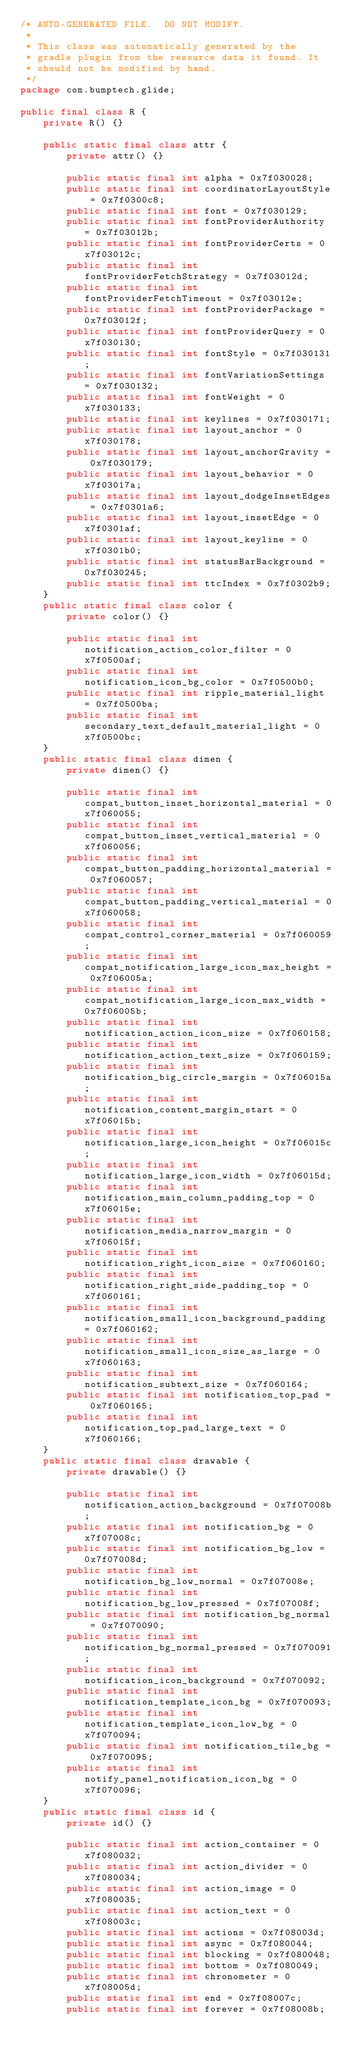<code> <loc_0><loc_0><loc_500><loc_500><_Java_>/* AUTO-GENERATED FILE.  DO NOT MODIFY.
 *
 * This class was automatically generated by the
 * gradle plugin from the resource data it found. It
 * should not be modified by hand.
 */
package com.bumptech.glide;

public final class R {
    private R() {}

    public static final class attr {
        private attr() {}

        public static final int alpha = 0x7f030028;
        public static final int coordinatorLayoutStyle = 0x7f0300c8;
        public static final int font = 0x7f030129;
        public static final int fontProviderAuthority = 0x7f03012b;
        public static final int fontProviderCerts = 0x7f03012c;
        public static final int fontProviderFetchStrategy = 0x7f03012d;
        public static final int fontProviderFetchTimeout = 0x7f03012e;
        public static final int fontProviderPackage = 0x7f03012f;
        public static final int fontProviderQuery = 0x7f030130;
        public static final int fontStyle = 0x7f030131;
        public static final int fontVariationSettings = 0x7f030132;
        public static final int fontWeight = 0x7f030133;
        public static final int keylines = 0x7f030171;
        public static final int layout_anchor = 0x7f030178;
        public static final int layout_anchorGravity = 0x7f030179;
        public static final int layout_behavior = 0x7f03017a;
        public static final int layout_dodgeInsetEdges = 0x7f0301a6;
        public static final int layout_insetEdge = 0x7f0301af;
        public static final int layout_keyline = 0x7f0301b0;
        public static final int statusBarBackground = 0x7f030245;
        public static final int ttcIndex = 0x7f0302b9;
    }
    public static final class color {
        private color() {}

        public static final int notification_action_color_filter = 0x7f0500af;
        public static final int notification_icon_bg_color = 0x7f0500b0;
        public static final int ripple_material_light = 0x7f0500ba;
        public static final int secondary_text_default_material_light = 0x7f0500bc;
    }
    public static final class dimen {
        private dimen() {}

        public static final int compat_button_inset_horizontal_material = 0x7f060055;
        public static final int compat_button_inset_vertical_material = 0x7f060056;
        public static final int compat_button_padding_horizontal_material = 0x7f060057;
        public static final int compat_button_padding_vertical_material = 0x7f060058;
        public static final int compat_control_corner_material = 0x7f060059;
        public static final int compat_notification_large_icon_max_height = 0x7f06005a;
        public static final int compat_notification_large_icon_max_width = 0x7f06005b;
        public static final int notification_action_icon_size = 0x7f060158;
        public static final int notification_action_text_size = 0x7f060159;
        public static final int notification_big_circle_margin = 0x7f06015a;
        public static final int notification_content_margin_start = 0x7f06015b;
        public static final int notification_large_icon_height = 0x7f06015c;
        public static final int notification_large_icon_width = 0x7f06015d;
        public static final int notification_main_column_padding_top = 0x7f06015e;
        public static final int notification_media_narrow_margin = 0x7f06015f;
        public static final int notification_right_icon_size = 0x7f060160;
        public static final int notification_right_side_padding_top = 0x7f060161;
        public static final int notification_small_icon_background_padding = 0x7f060162;
        public static final int notification_small_icon_size_as_large = 0x7f060163;
        public static final int notification_subtext_size = 0x7f060164;
        public static final int notification_top_pad = 0x7f060165;
        public static final int notification_top_pad_large_text = 0x7f060166;
    }
    public static final class drawable {
        private drawable() {}

        public static final int notification_action_background = 0x7f07008b;
        public static final int notification_bg = 0x7f07008c;
        public static final int notification_bg_low = 0x7f07008d;
        public static final int notification_bg_low_normal = 0x7f07008e;
        public static final int notification_bg_low_pressed = 0x7f07008f;
        public static final int notification_bg_normal = 0x7f070090;
        public static final int notification_bg_normal_pressed = 0x7f070091;
        public static final int notification_icon_background = 0x7f070092;
        public static final int notification_template_icon_bg = 0x7f070093;
        public static final int notification_template_icon_low_bg = 0x7f070094;
        public static final int notification_tile_bg = 0x7f070095;
        public static final int notify_panel_notification_icon_bg = 0x7f070096;
    }
    public static final class id {
        private id() {}

        public static final int action_container = 0x7f080032;
        public static final int action_divider = 0x7f080034;
        public static final int action_image = 0x7f080035;
        public static final int action_text = 0x7f08003c;
        public static final int actions = 0x7f08003d;
        public static final int async = 0x7f080044;
        public static final int blocking = 0x7f080048;
        public static final int bottom = 0x7f080049;
        public static final int chronometer = 0x7f08005d;
        public static final int end = 0x7f08007c;
        public static final int forever = 0x7f08008b;</code> 